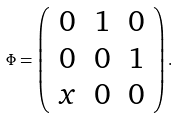<formula> <loc_0><loc_0><loc_500><loc_500>\Phi = \left ( \begin{array} { c c c } 0 & 1 & 0 \\ 0 & 0 & 1 \\ x & 0 & 0 \end{array} \right ) .</formula> 